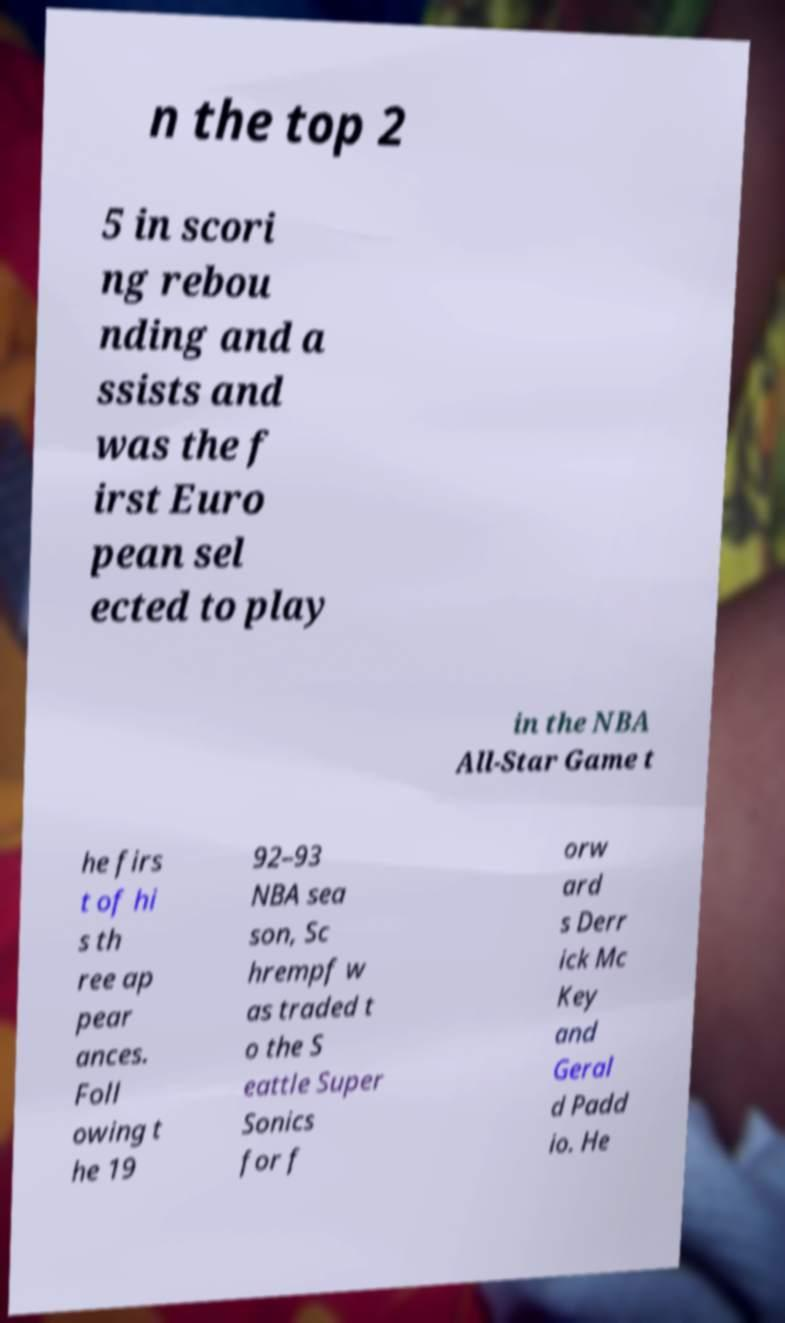I need the written content from this picture converted into text. Can you do that? n the top 2 5 in scori ng rebou nding and a ssists and was the f irst Euro pean sel ected to play in the NBA All-Star Game t he firs t of hi s th ree ap pear ances. Foll owing t he 19 92–93 NBA sea son, Sc hrempf w as traded t o the S eattle Super Sonics for f orw ard s Derr ick Mc Key and Geral d Padd io. He 